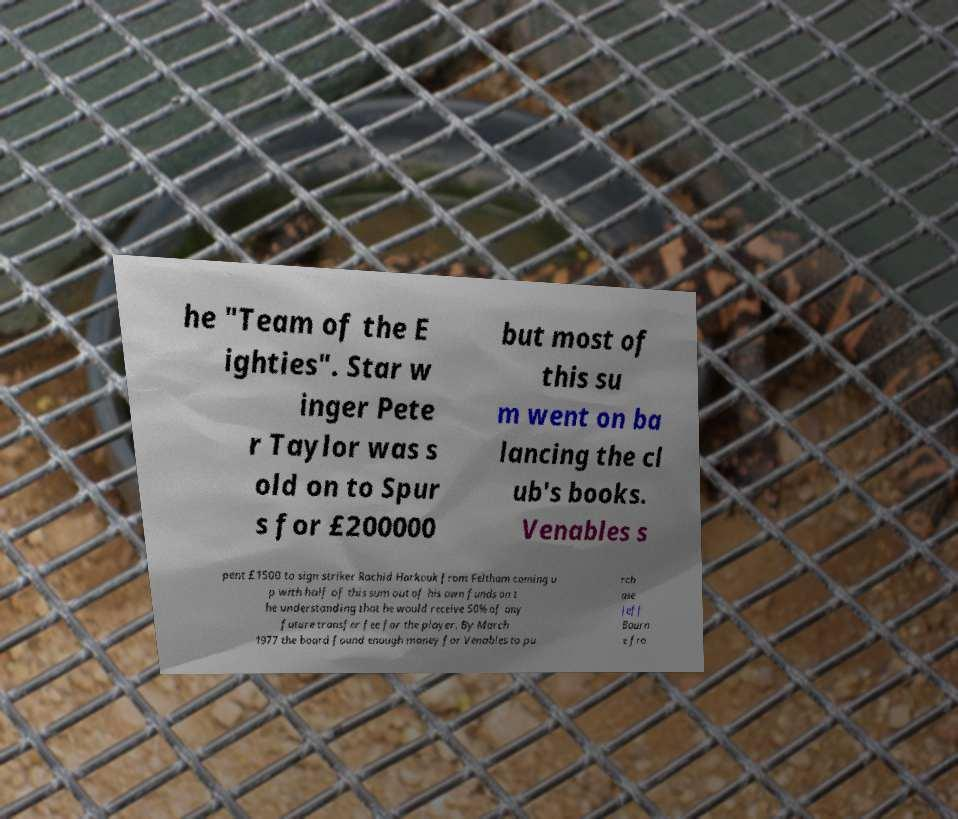Could you assist in decoding the text presented in this image and type it out clearly? he "Team of the E ighties". Star w inger Pete r Taylor was s old on to Spur s for £200000 but most of this su m went on ba lancing the cl ub's books. Venables s pent £1500 to sign striker Rachid Harkouk from Feltham coming u p with half of this sum out of his own funds on t he understanding that he would receive 50% of any future transfer fee for the player. By March 1977 the board found enough money for Venables to pu rch ase Jeff Bourn e fro 